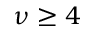<formula> <loc_0><loc_0><loc_500><loc_500>\nu \geq 4</formula> 